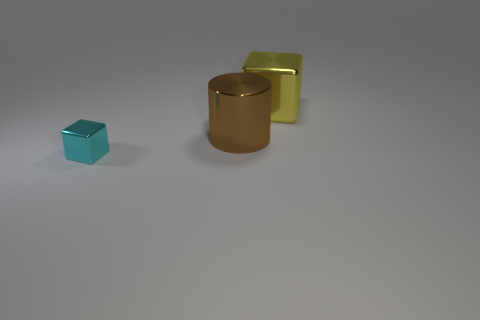Add 1 small things. How many objects exist? 4 Subtract all blocks. How many objects are left? 1 Add 1 yellow metal cubes. How many yellow metal cubes are left? 2 Add 3 small balls. How many small balls exist? 3 Subtract 0 purple cubes. How many objects are left? 3 Subtract all shiny blocks. Subtract all large metallic cylinders. How many objects are left? 0 